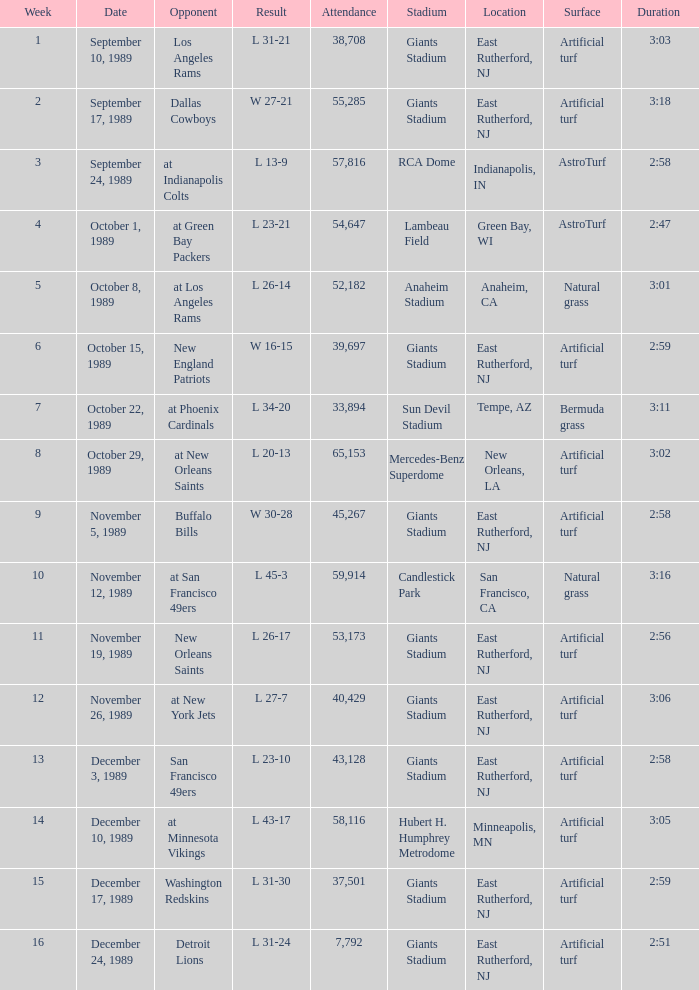The Detroit Lions were played against what week? 16.0. 